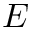Convert formula to latex. <formula><loc_0><loc_0><loc_500><loc_500>E</formula> 